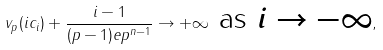<formula> <loc_0><loc_0><loc_500><loc_500>v _ { p } ( i c _ { i } ) + \frac { i - 1 } { ( p - 1 ) e p ^ { n - 1 } } \rightarrow + \infty \text {  as $i\rightarrow -\infty$} ,</formula> 